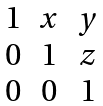Convert formula to latex. <formula><loc_0><loc_0><loc_500><loc_500>\begin{matrix} 1 & x & y \\ 0 & 1 & z \\ 0 & 0 & 1 \end{matrix}</formula> 